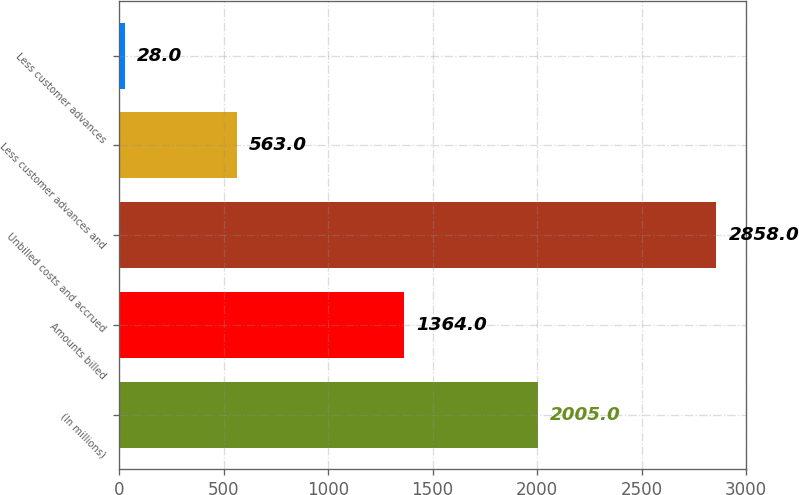Convert chart. <chart><loc_0><loc_0><loc_500><loc_500><bar_chart><fcel>(In millions)<fcel>Amounts billed<fcel>Unbilled costs and accrued<fcel>Less customer advances and<fcel>Less customer advances<nl><fcel>2005<fcel>1364<fcel>2858<fcel>563<fcel>28<nl></chart> 